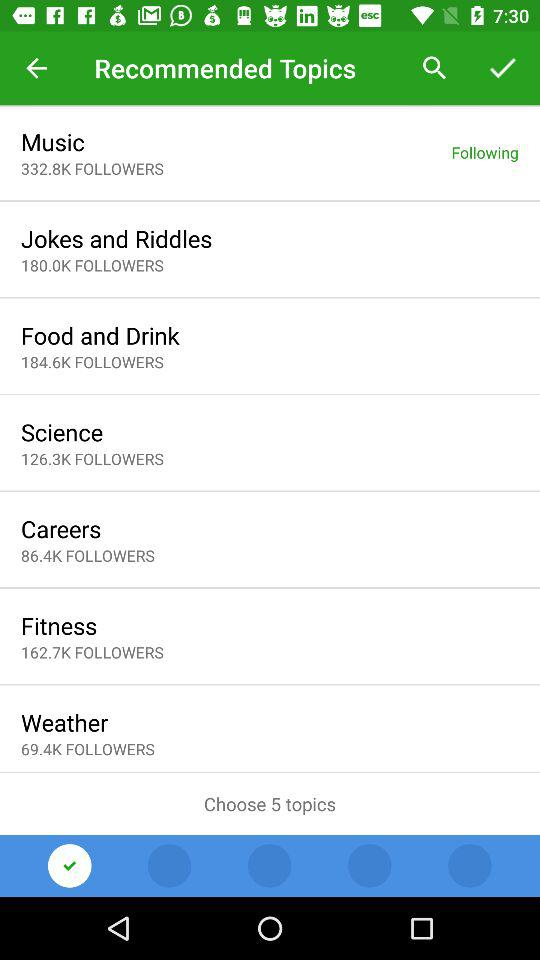Whom are we following? You are following "Music". 